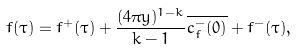<formula> <loc_0><loc_0><loc_500><loc_500>f ( \tau ) = f ^ { + } ( \tau ) + \frac { ( 4 \pi y ) ^ { 1 - k } } { k - 1 } \overline { c _ { f } ^ { - } ( 0 ) } + f ^ { - } ( \tau ) ,</formula> 